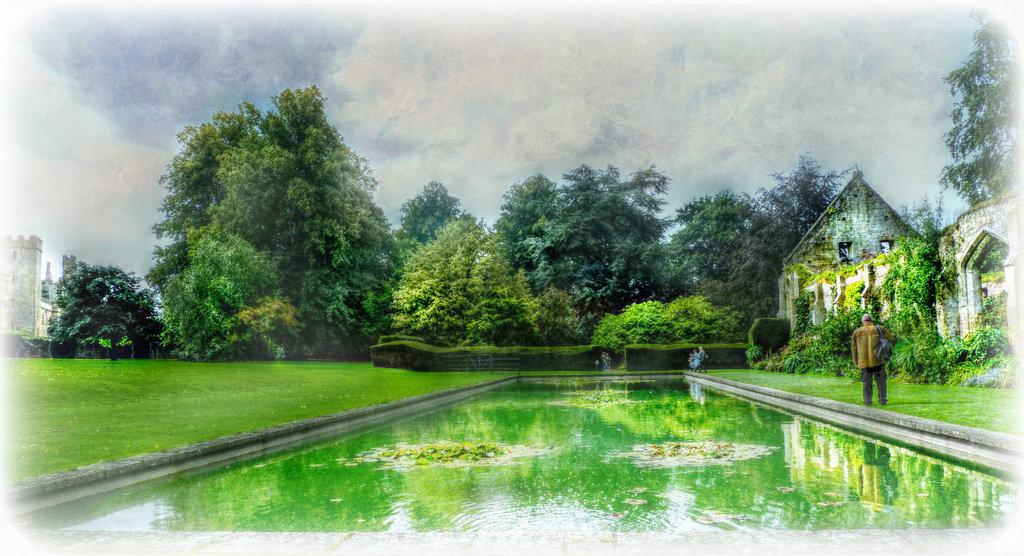How would you summarize this image in a sentence or two? In this image in front there is water. At the bottom of the image there is grass on the surface. There are people. In the background of the image there are trees, buildings and sky. 